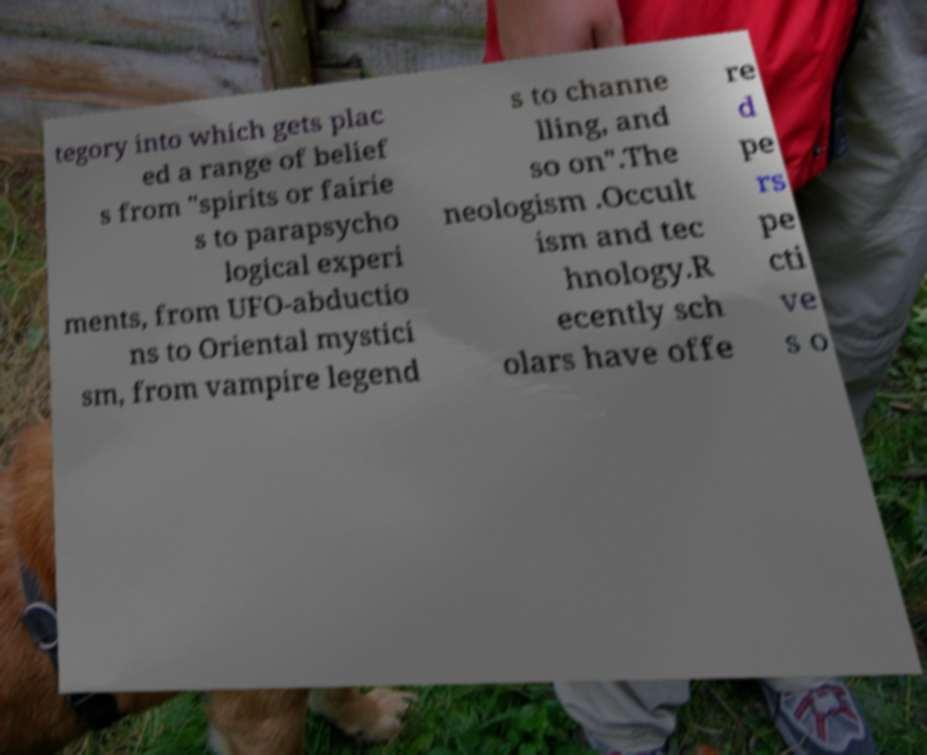Please identify and transcribe the text found in this image. tegory into which gets plac ed a range of belief s from "spirits or fairie s to parapsycho logical experi ments, from UFO-abductio ns to Oriental mystici sm, from vampire legend s to channe lling, and so on".The neologism .Occult ism and tec hnology.R ecently sch olars have offe re d pe rs pe cti ve s o 